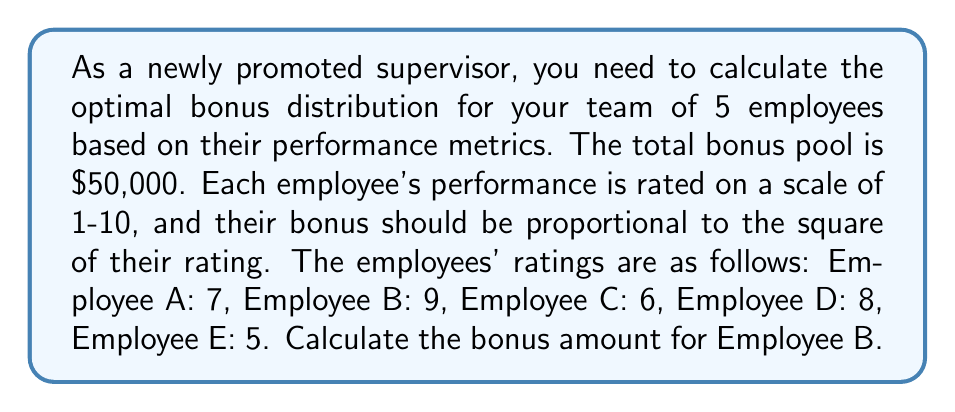Help me with this question. 1. First, we need to calculate the sum of the squared ratings for all employees:

   $$(7^2 + 9^2 + 6^2 + 8^2 + 5^2) = 49 + 81 + 36 + 64 + 25 = 255$$

2. Now, we calculate the bonus multiplier by dividing the total bonus pool by the sum of squared ratings:

   $$\text{Bonus Multiplier} = \frac{\$50,000}{255} \approx \$196.08$$

3. For each employee, their bonus will be their squared rating multiplied by this bonus multiplier. For Employee B with a rating of 9:

   $$\text{Employee B Bonus} = 9^2 \times \$196.08 = 81 \times \$196.08 = \$15,882.48$$

4. To verify, we can calculate the bonuses for all employees:
   - Employee A: $7^2 \times \$196.08 = \$9,607.92$
   - Employee B: $9^2 \times \$196.08 = \$15,882.48$
   - Employee C: $6^2 \times \$196.08 = \$7,058.88$
   - Employee D: $8^2 \times \$196.08 = \$12,549.12$
   - Employee E: $5^2 \times \$196.08 = \$4,902.00$

   The sum of all bonuses is indeed $50,000.40 (the small discrepancy is due to rounding).
Answer: $15,882.48 